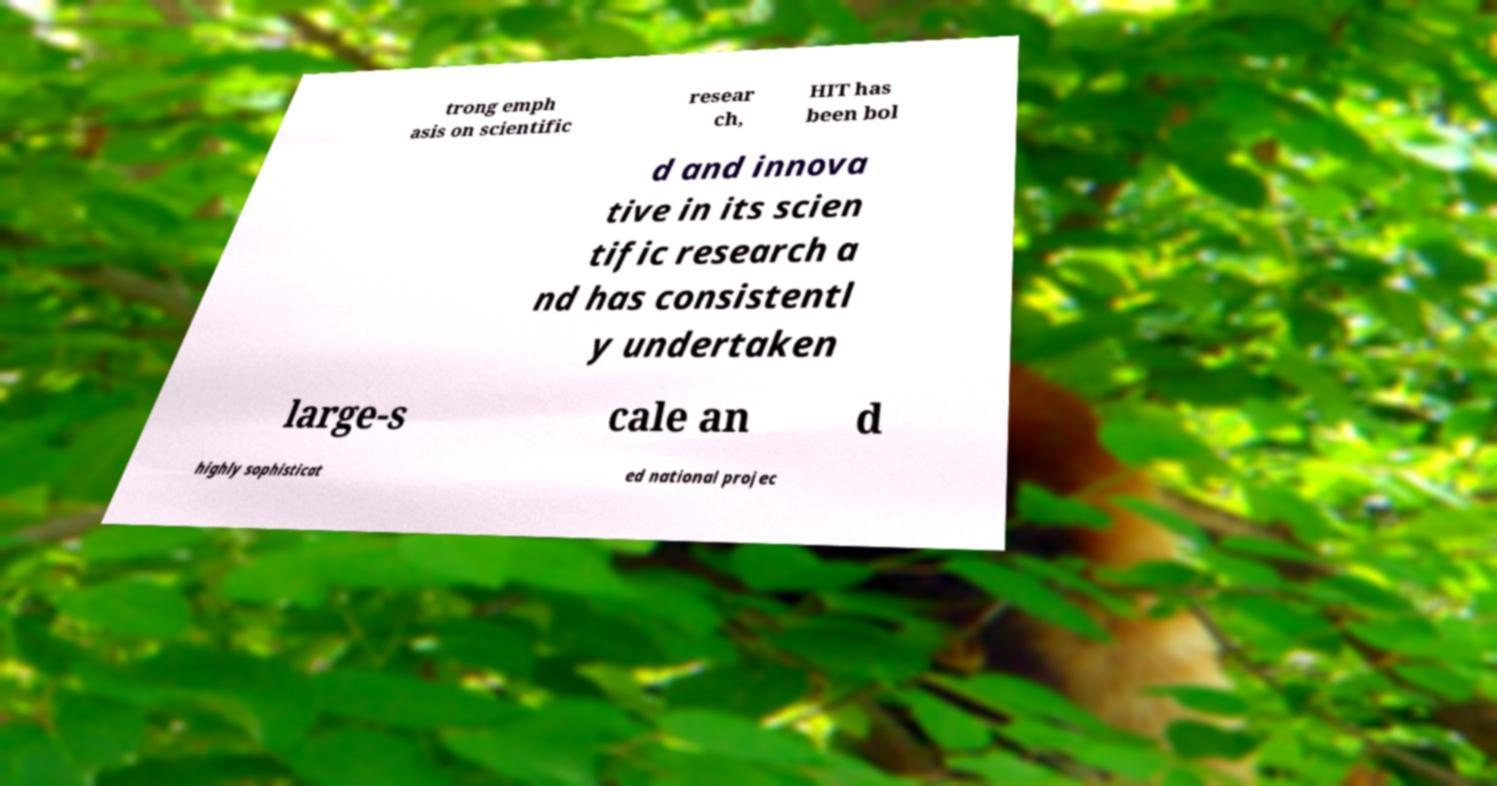There's text embedded in this image that I need extracted. Can you transcribe it verbatim? trong emph asis on scientific resear ch, HIT has been bol d and innova tive in its scien tific research a nd has consistentl y undertaken large-s cale an d highly sophisticat ed national projec 